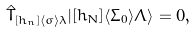Convert formula to latex. <formula><loc_0><loc_0><loc_500><loc_500>\hat { T } _ { [ h _ { n } ] \langle \sigma \rangle \lambda } | [ h _ { N } ] \langle \Sigma _ { 0 } \rangle \Lambda \rangle = 0 ,</formula> 